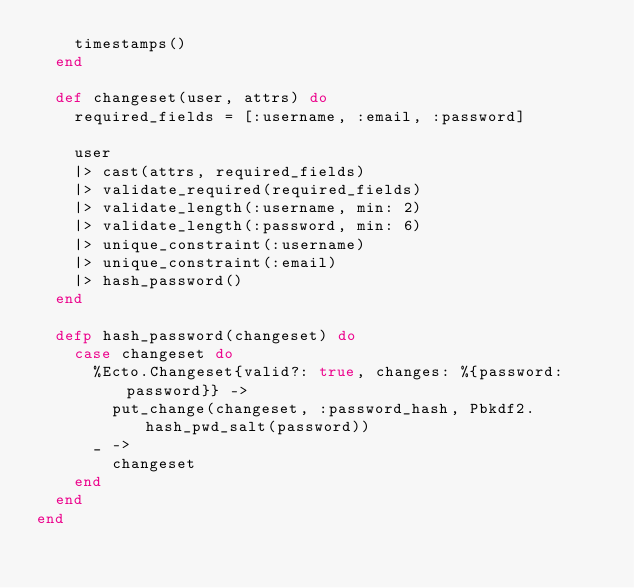Convert code to text. <code><loc_0><loc_0><loc_500><loc_500><_Elixir_>    timestamps()
  end

  def changeset(user, attrs) do
    required_fields = [:username, :email, :password]
    
    user
    |> cast(attrs, required_fields)
    |> validate_required(required_fields)
    |> validate_length(:username, min: 2)
    |> validate_length(:password, min: 6)
    |> unique_constraint(:username)
    |> unique_constraint(:email)
    |> hash_password()
  end

  defp hash_password(changeset) do
    case changeset do
      %Ecto.Changeset{valid?: true, changes: %{password: password}} ->
        put_change(changeset, :password_hash, Pbkdf2.hash_pwd_salt(password))
      _ ->
        changeset
    end
  end
end
</code> 